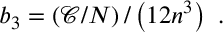Convert formula to latex. <formula><loc_0><loc_0><loc_500><loc_500>b _ { 3 } = \left ( \mathcal { C } / N \right ) / \left ( 1 2 n ^ { 3 } \right ) \ .</formula> 